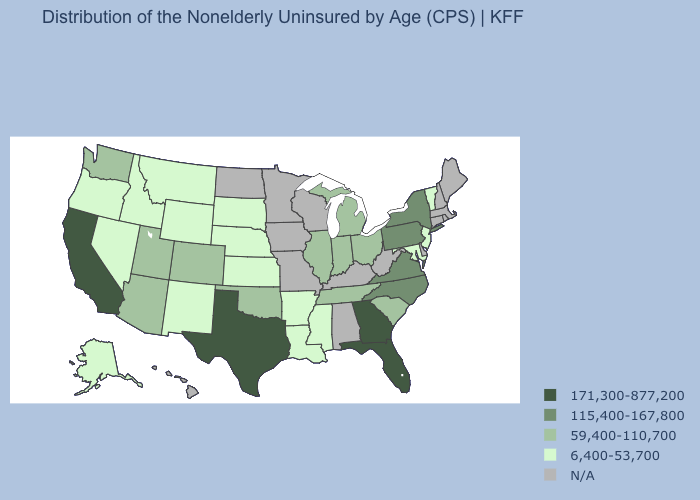Name the states that have a value in the range 115,400-167,800?
Short answer required. New York, North Carolina, Pennsylvania, Virginia. Which states have the highest value in the USA?
Be succinct. California, Florida, Georgia, Texas. Which states have the lowest value in the USA?
Short answer required. Alaska, Arkansas, Idaho, Kansas, Louisiana, Maryland, Mississippi, Montana, Nebraska, Nevada, New Jersey, New Mexico, Oregon, South Dakota, Vermont, Wyoming. Which states have the lowest value in the South?
Short answer required. Arkansas, Louisiana, Maryland, Mississippi. What is the value of Connecticut?
Quick response, please. N/A. What is the highest value in the West ?
Quick response, please. 171,300-877,200. Among the states that border New York , does New Jersey have the highest value?
Be succinct. No. Name the states that have a value in the range 115,400-167,800?
Write a very short answer. New York, North Carolina, Pennsylvania, Virginia. What is the value of Montana?
Answer briefly. 6,400-53,700. Which states have the lowest value in the USA?
Write a very short answer. Alaska, Arkansas, Idaho, Kansas, Louisiana, Maryland, Mississippi, Montana, Nebraska, Nevada, New Jersey, New Mexico, Oregon, South Dakota, Vermont, Wyoming. What is the lowest value in the South?
Answer briefly. 6,400-53,700. What is the highest value in the USA?
Be succinct. 171,300-877,200. Name the states that have a value in the range 59,400-110,700?
Be succinct. Arizona, Colorado, Illinois, Indiana, Michigan, Ohio, Oklahoma, South Carolina, Tennessee, Utah, Washington. 